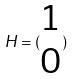<formula> <loc_0><loc_0><loc_500><loc_500>H = ( \begin{matrix} 1 \\ 0 \end{matrix} )</formula> 